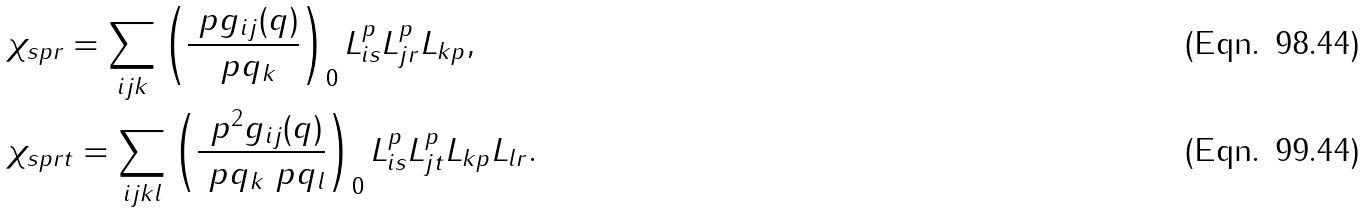Convert formula to latex. <formula><loc_0><loc_0><loc_500><loc_500>& \chi _ { s p r } = \sum _ { i j k } \left ( \frac { \ p g _ { i j } ( q ) } { \ p q _ { k } } \right ) _ { 0 } L ^ { p } _ { i s } L ^ { p } _ { j r } L _ { k p } , \\ & \chi _ { s p r t } = \sum _ { i j k l } \left ( \frac { \ p ^ { 2 } g _ { i j } ( q ) } { \ p q _ { k } \ p q _ { l } } \right ) _ { 0 } L ^ { p } _ { i s } L ^ { p } _ { j t } L _ { k p } L _ { l r } .</formula> 